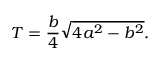<formula> <loc_0><loc_0><loc_500><loc_500>T = { \frac { b } { 4 } } { \sqrt { 4 a ^ { 2 } - b ^ { 2 } } } .</formula> 